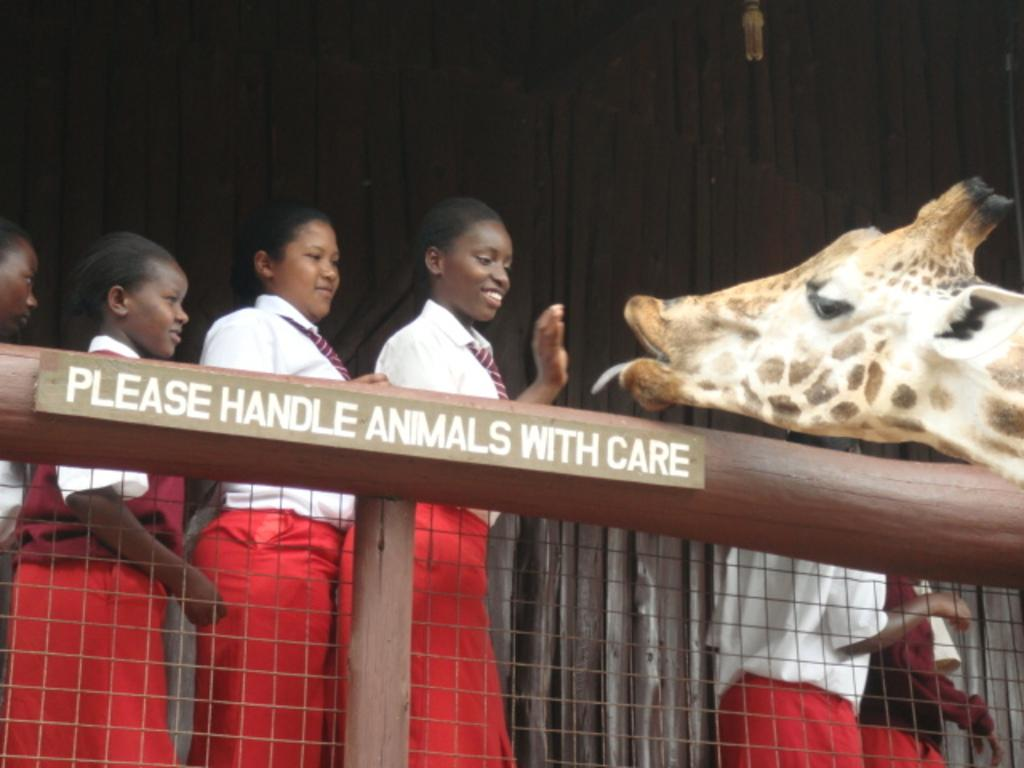How many people are in the image? There is a group of people in the image. Where are the people standing in relation to the fence? The people are standing beside a fence in the image. What type of objects can be seen in the image besides the people and fence? There are wooden poles, a board with text, a giraffe, a curtain, and a light bulb in the image. What type of reaction does the fork have to the giraffe in the image? There is no fork present in the image, so it cannot have any reaction to the giraffe. 